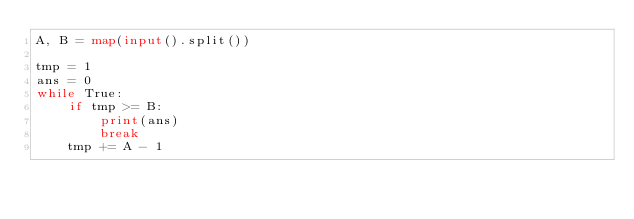<code> <loc_0><loc_0><loc_500><loc_500><_Python_>A, B = map(input().split())

tmp = 1
ans = 0
while True:
    if tmp >= B:
        print(ans)
        break
    tmp += A - 1
</code> 